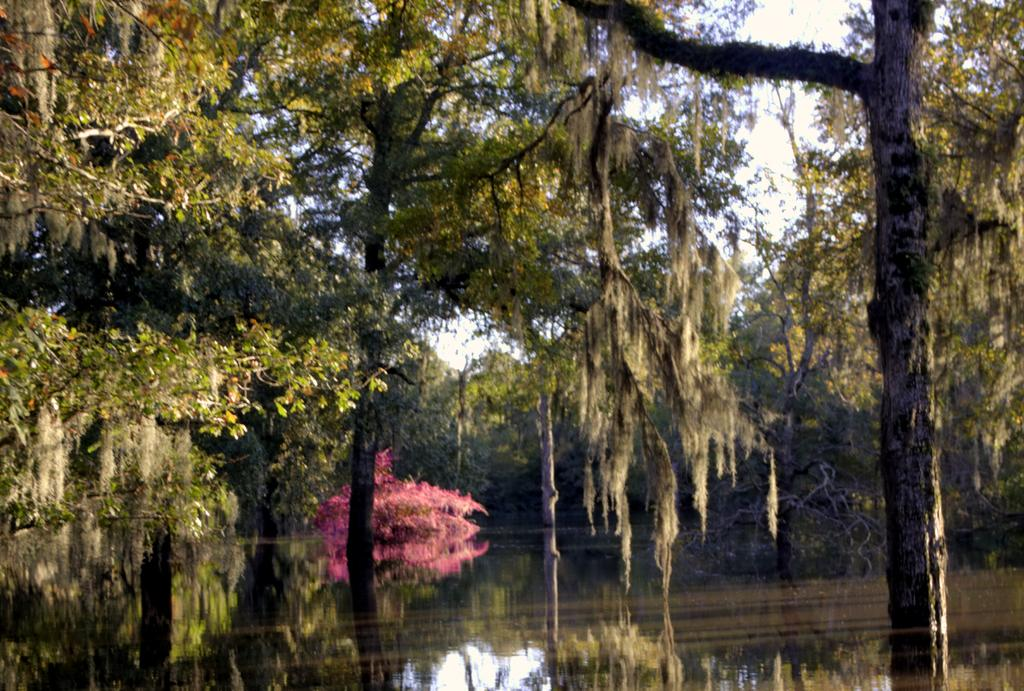What type of natural environment is depicted in the image? The image features many trees, suggesting a forest or wooded area. What else can be seen in the image besides trees? There is water visible in the image. What is visible in the background of the image? The sky is visible in the background of the image. How does the presence of water affect the overall scene? The presence of water adds a sense of tranquility and natural beauty to the scene. What type of jewel can be seen hanging from the trees in the image? There are no jewels present in the image; it features trees and water in a natural setting. 